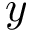Convert formula to latex. <formula><loc_0><loc_0><loc_500><loc_500>y</formula> 